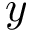Convert formula to latex. <formula><loc_0><loc_0><loc_500><loc_500>y</formula> 